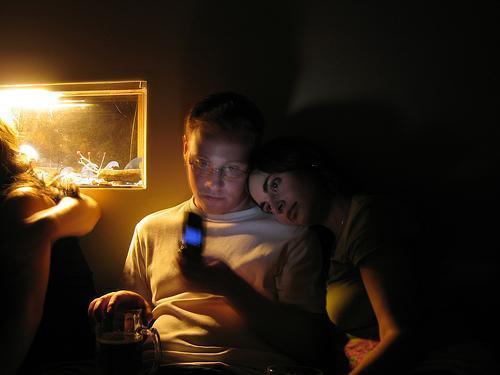How many people are there?
Give a very brief answer. 2. 